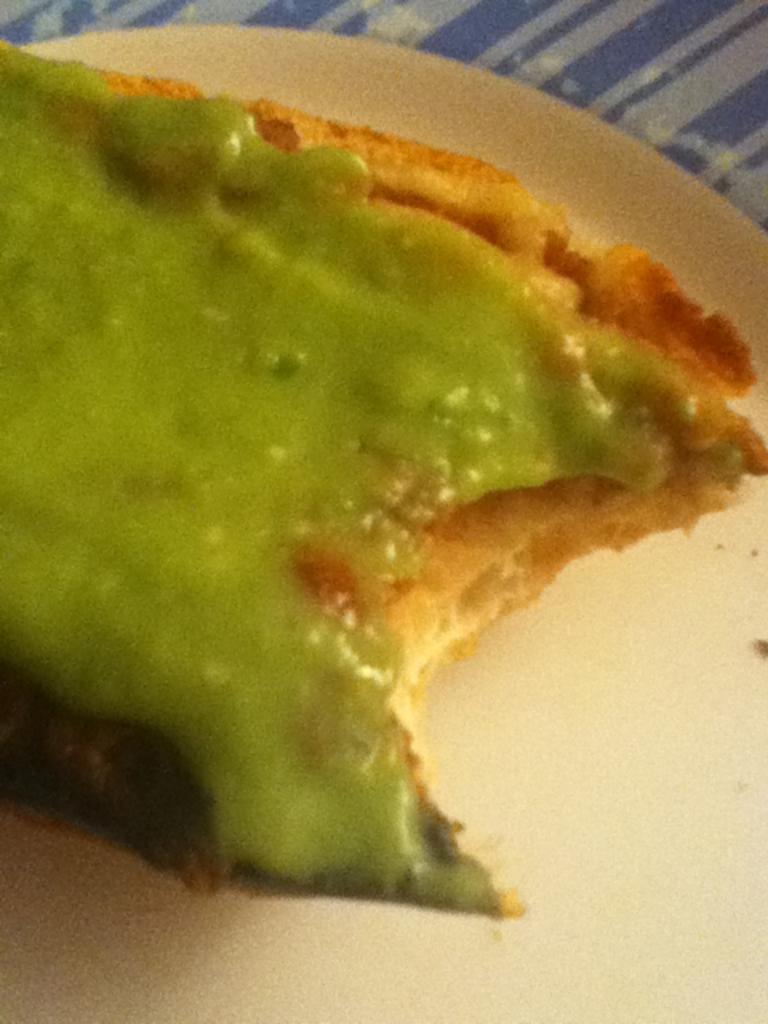In one or two sentences, can you explain what this image depicts? This image consist of food which is on the plate in the front. 